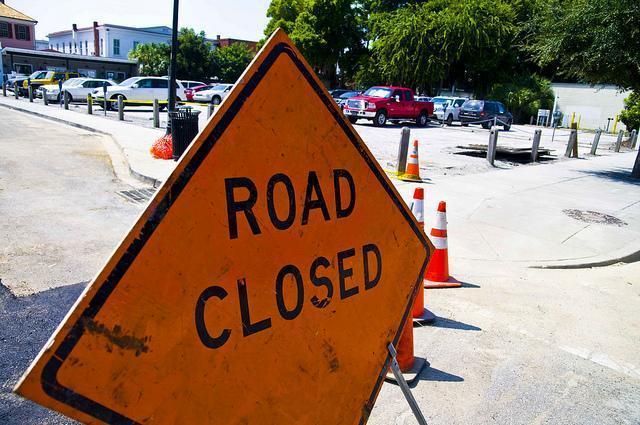How many people are wearing white jerseys?
Give a very brief answer. 0. 